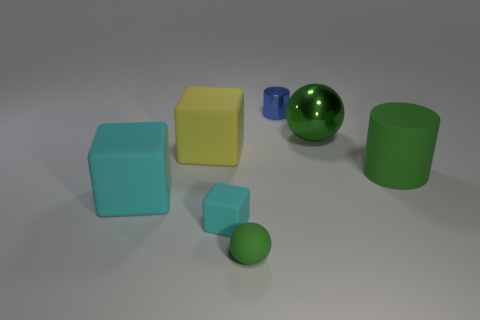Add 2 cyan objects. How many objects exist? 9 Subtract all tiny cubes. How many cubes are left? 2 Subtract all red spheres. How many cyan cubes are left? 2 Subtract all cylinders. How many objects are left? 5 Subtract all purple cubes. Subtract all yellow balls. How many cubes are left? 3 Add 3 small blue objects. How many small blue objects are left? 4 Add 4 small cyan rubber objects. How many small cyan rubber objects exist? 5 Subtract 0 yellow cylinders. How many objects are left? 7 Subtract all tiny cyan shiny spheres. Subtract all green objects. How many objects are left? 4 